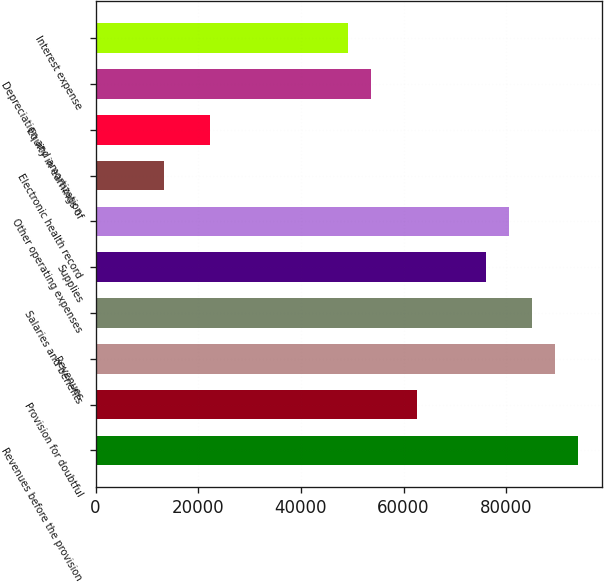Convert chart. <chart><loc_0><loc_0><loc_500><loc_500><bar_chart><fcel>Revenues before the provision<fcel>Provision for doubtful<fcel>Revenues<fcel>Salaries and benefits<fcel>Supplies<fcel>Other operating expenses<fcel>Electronic health record<fcel>Equity in earnings of<fcel>Depreciation and amortization<fcel>Interest expense<nl><fcel>93964.3<fcel>62644.2<fcel>89490<fcel>85015.7<fcel>76067.1<fcel>80541.4<fcel>13426.9<fcel>22375.5<fcel>53695.6<fcel>49221.3<nl></chart> 